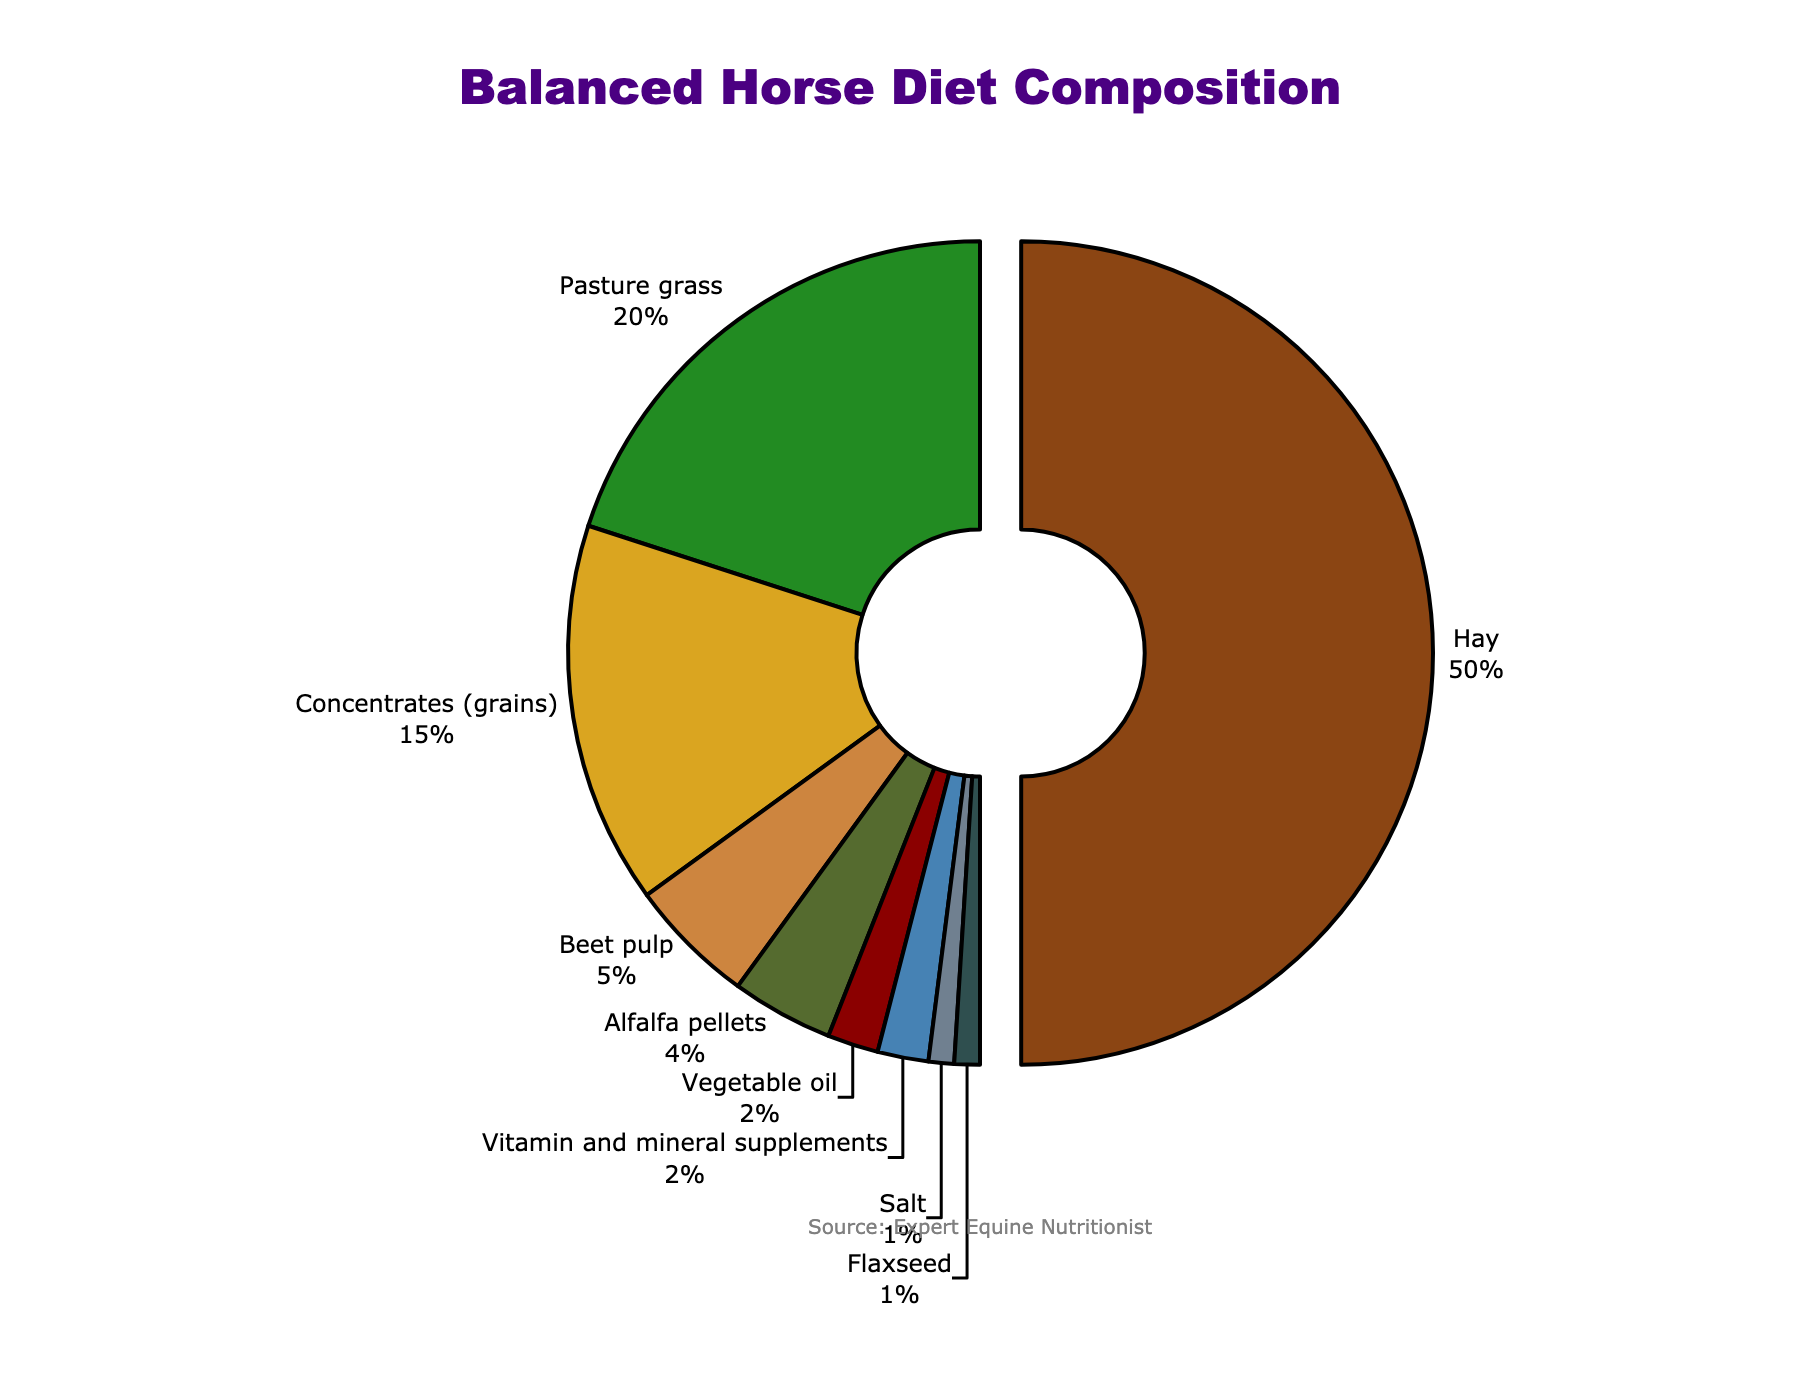What type of feed constitutes the largest percentage of the balanced horse diet? By looking at the pie chart, it's easy to identify that "Hay" occupies the largest segment of the chart. It is also pulled slightly away from the center, drawing attention.
Answer: Hay What is the combined percentage of concentrates (grains) and beet pulp in the diet? First, locate the percentages for "Concentrates (grains)" (15%) and "Beet pulp" (5%) in the pie chart. Add these two percentages together: 15% + 5% = 20%.
Answer: 20% How much larger is the percentage of hay compared to alfalfa pellets? Identify the percentages for "Hay" (50%) and "Alfalfa pellets" (4%) in the pie chart. Subtract the percentage of "Alfalfa pellets" from "Hay": 50% - 4% = 46%.
Answer: 46% What total percentage of the diet is made up by the least represented feeds (vegetable oil, vitamin and mineral supplements, salt, and flaxseed)? Identify the percentages for "Vegetable oil" (2%), "Vitamin and mineral supplements" (2%), "Salt" (1%), and "Flaxseed" (1%) in the pie chart. Add them together: 2% + 2% + 1% + 1% = 6%.
Answer: 6% Is pasture grass more or less than half of the hay's percentage? Identify the percentages for "Hay" (50%) and "Pasture grass" (20%) in the pie chart. Calculate half of "Hay"'s percentage: 50% / 2 = 25%, and then compare this with "Pasture grass". Since 20% < 25%, the percentage of "Pasture grass" is less than half of "Hay".
Answer: Less What distinguishes the visual representation of the largest feed type in the chart? The largest feed type is "Hay," which is visually distinguished by being pulled slightly away from the center of the pie chart, making it stand out.
Answer: Pulled out If you combine pasture grass and alfalfa pellets, what is their total percentage of the diet? Identify the percentages of "Pasture grass" (20%) and "Alfalfa pellets" (4%) in the pie chart. Add them together: 20% + 4% = 24%.
Answer: 24% Which type of feed is represented by the green section in the pie chart? By examining the color sections in the pie chart, the green color corresponds to "Pasture grass."
Answer: Pasture grass What percentage of the diet is represented by feeds that individually make up less than 5% each? Identify the feeds that are less than 5% each: "Beet pulp" (5%), "Alfalfa pellets" (4%), "Vegetable oil" (2%), "Vitamin and mineral supplements" (2%), "Salt" (1%), and "Flaxseed" (1%). The total is 4% + 2% + 2% + 1% + 1% = 10% (excluding "Beet pulp" as it is exactly 5%, not less than 5%).
Answer: 10% 